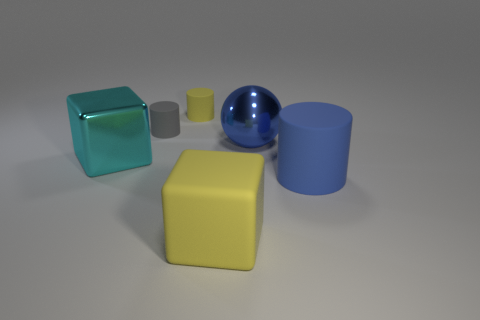Subtract all tiny rubber cylinders. How many cylinders are left? 1 Add 3 tiny blue metallic balls. How many objects exist? 9 Subtract all blocks. How many objects are left? 4 Add 2 gray objects. How many gray objects are left? 3 Add 2 yellow cylinders. How many yellow cylinders exist? 3 Subtract 0 brown cylinders. How many objects are left? 6 Subtract all big blue matte objects. Subtract all metallic blocks. How many objects are left? 4 